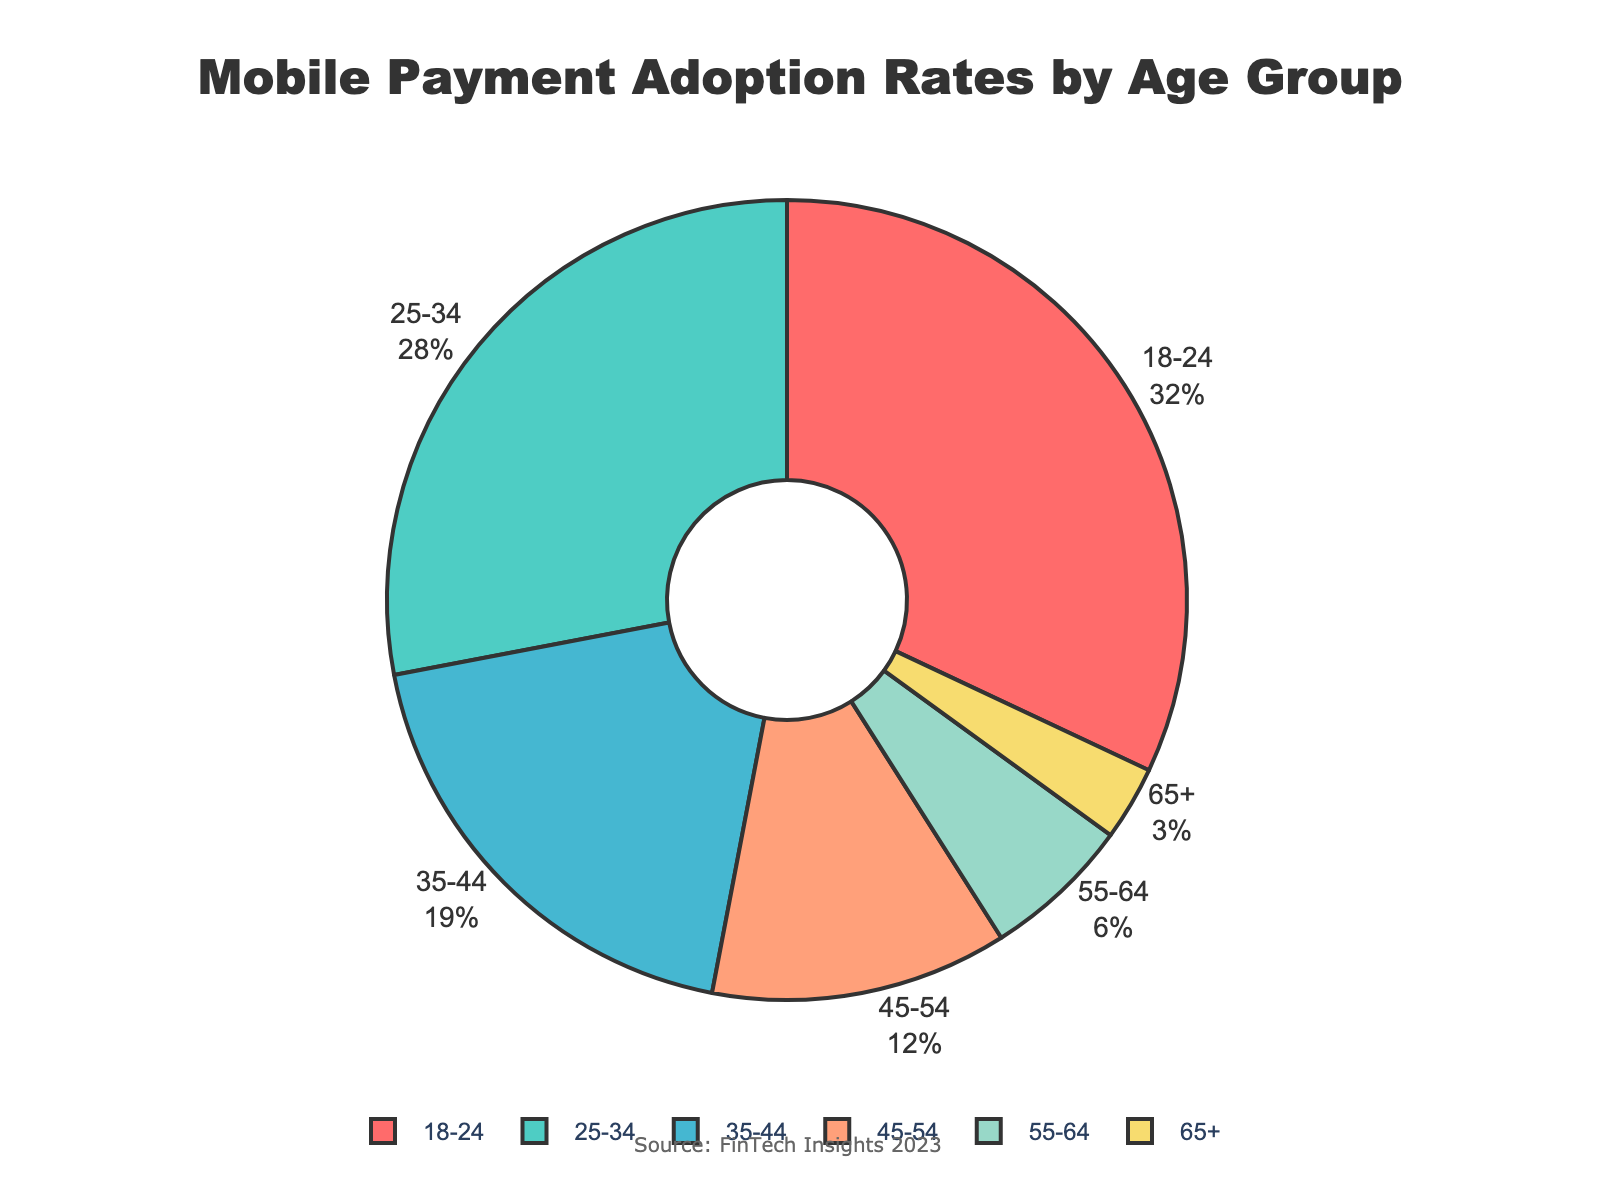What age group has the highest mobile payment adoption rate? The age group with the highest adoption rate is the one with the largest segment in the pie chart. The largest segment is for the 18-24 age group.
Answer: 18-24 What is the combined adoption rate for the 35-44 and 45-54 age groups? To find the combined adoption rate, add the adoption rates of the 35-44 and 45-54 age groups: 19% + 12%.
Answer: 31% Which age group has the smallest adoption rate and what is the percentage? The smallest segment in the pie chart represents the 65+ age group. The adoption rate for this segment is 3%.
Answer: 65+, 3% Are the combined adoption rates for the 55-64 and 65+ age groups greater than the adoption rate of the 25-34 age group? First, find the combined adoption rates for 55-64 and 65+ age groups: 6% + 3% = 9%. Then, compare it to the adoption rate of the 25-34 age group, which is 28%. 9% is less than 28%.
Answer: No What is the adoption rate difference between the 18-24 and 45-54 age groups? Subtract the adoption rate of the 45-54 age group (12%) from the 18-24 age group (32%): 32% - 12%.
Answer: 20% How many age groups have an adoption rate above 20%? Identify groups with rates higher than 20%: 18-24 (32%) and 25-34 (28%). There are two such groups.
Answer: 2 Which age group has an adoption rate exactly three times that of the 65+ age group? The 65+ age group's rate is 3%. Three times this rate is 9%. The closest group is the 55-64 age group with 6%, which is not exactly three times. Hence, no age group fits exactly.
Answer: None Do the combined rates of the 18-24 and 55-64 age groups exceed 35%? Calculate combined rates: 32% (18-24) + 6% (55-64) = 38%. Since 38% > 35%, the answer is yes.
Answer: Yes List the age groups in descending order of their adoption rates. Arrange the age groups by their rates: 18-24 (32%), 25-34 (28%), 35-44 (19%), 45-54 (12%), 55-64 (6%), 65+ (3%).
Answer: 18-24, 25-34, 35-44, 45-54, 55-64, 65+ 